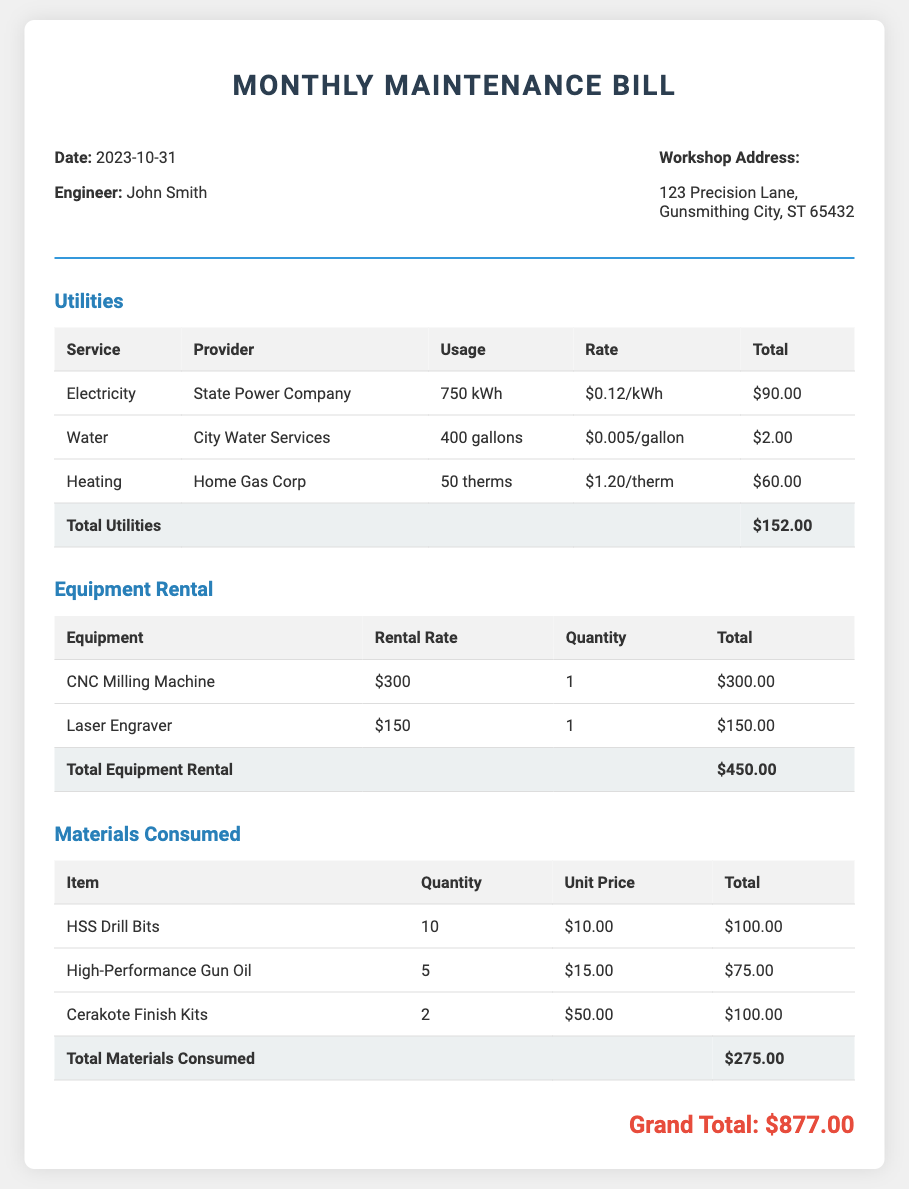what is the date of the bill? The date of the bill is stated at the top of the document as 2023-10-31.
Answer: 2023-10-31 who is the engineer listed in the bill? The engineer's name is provided in the header section of the document as John Smith.
Answer: John Smith what is the total for utilities? The total for utilities is calculated and presented in the utilities section as $152.00.
Answer: $152.00 how much is the rental rate for the CNC Milling Machine? The rental rate for the CNC Milling Machine is specified in the equipment rental section as $300.
Answer: $300 what is the grand total of the bill? The grand total is highlighted at the end of the document as the sum of all totals, which is $877.00.
Answer: $877.00 how many gallons of water were used? The quantity of water usage is recorded in the utilities section as 400 gallons.
Answer: 400 gallons what is the unit price of High-Performance Gun Oil? The unit price for High-Performance Gun Oil is detailed in the materials consumed section as $15.00.
Answer: $15.00 who provides heating services? The heating service provider is identified in the utilities section as Home Gas Corp.
Answer: Home Gas Corp what is the total cost for materials consumed? The total cost for materials consumed is summarized in the materials section as $275.00.
Answer: $275.00 